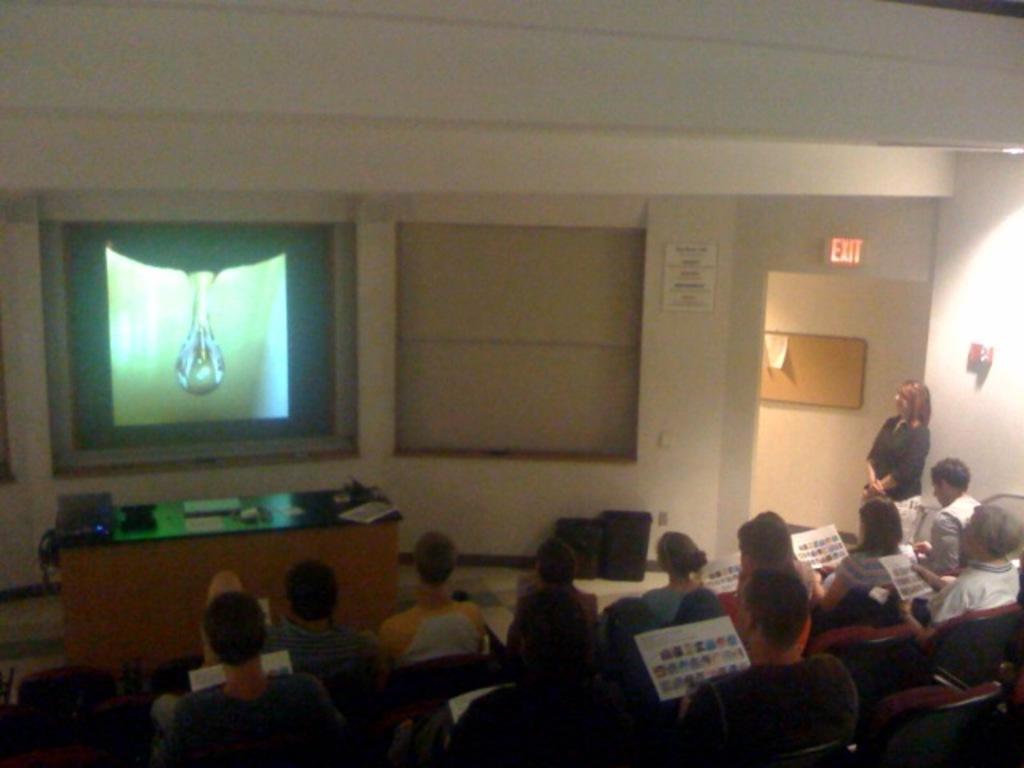Can you describe this image briefly? In this picture I can see group of people are sitting on the chairs. Some are holding some objects. On the right side I can see a woman is standing and board attached to the wall. On the left side I can see a projector screen and a table on which I can see some objects on it. 